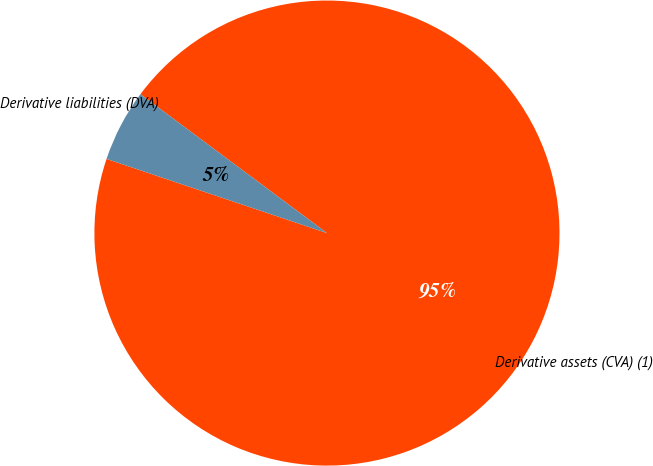<chart> <loc_0><loc_0><loc_500><loc_500><pie_chart><fcel>Derivative assets (CVA) (1)<fcel>Derivative liabilities (DVA)<nl><fcel>94.98%<fcel>5.02%<nl></chart> 